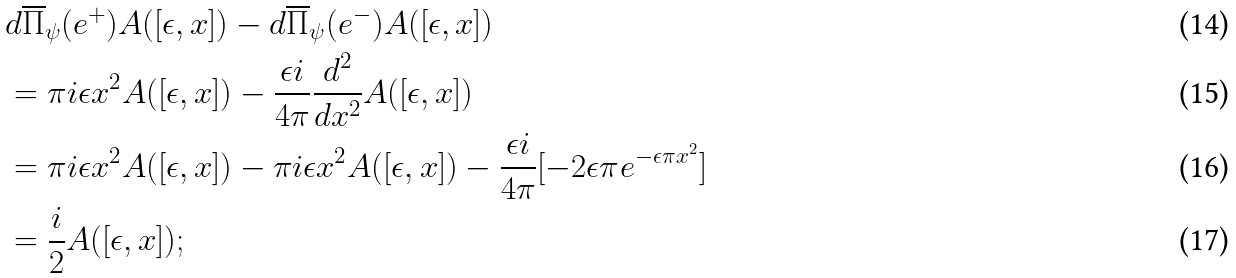Convert formula to latex. <formula><loc_0><loc_0><loc_500><loc_500>& d \overline { \Pi } _ { \psi } ( e ^ { + } ) A ( [ \epsilon , x ] ) - d \overline { \Pi } _ { \psi } ( e ^ { - } ) A ( [ \epsilon , x ] ) \\ & = \pi i \epsilon x ^ { 2 } A ( [ \epsilon , x ] ) - \frac { \epsilon i } { 4 \pi } \frac { d ^ { 2 } } { d x ^ { 2 } } A ( [ \epsilon , x ] ) \\ & = \pi i \epsilon x ^ { 2 } A ( [ \epsilon , x ] ) - \pi i \epsilon x ^ { 2 } A ( [ \epsilon , x ] ) - \frac { \epsilon i } { 4 \pi } [ - 2 \epsilon \pi e ^ { - \epsilon \pi x ^ { 2 } } ] \\ & = \frac { i } { 2 } A ( [ \epsilon , x ] ) ;</formula> 